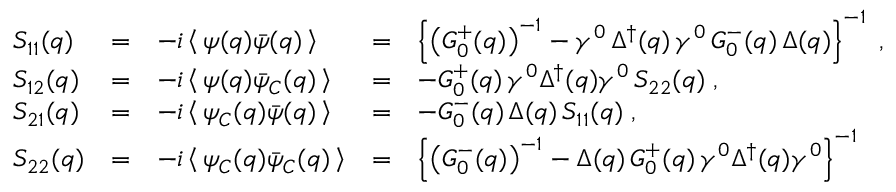Convert formula to latex. <formula><loc_0><loc_0><loc_500><loc_500>\begin{array} { l c l c l } { { S _ { 1 1 } ( q ) } } & { = } & { { - i \left \langle \, \psi ( q ) \bar { \psi } ( q ) \, \right \rangle } } & { = } & { { \left \{ \left ( G _ { 0 } ^ { + } ( q ) \right ) ^ { - 1 } - \gamma ^ { 0 } \, \Delta ^ { \dagger } ( q ) \, \gamma ^ { 0 } \, G _ { 0 } ^ { - } ( q ) \, \Delta ( q ) \right \} ^ { - 1 } \, , } } \\ { { S _ { 1 2 } ( q ) } } & { = } & { { - i \left \langle \, \psi ( q ) \bar { \psi } _ { C } ( q ) \, \right \rangle } } & { = } & { { - G _ { 0 } ^ { + } ( q ) \, \gamma ^ { 0 } \Delta ^ { \dagger } ( q ) \gamma ^ { 0 } \, S _ { 2 2 } ( q ) \, , } } \\ { { S _ { 2 1 } ( q ) } } & { = } & { { - i \left \langle \, \psi _ { C } ( q ) \bar { \psi } ( q ) \, \right \rangle } } & { = } & { { - G _ { 0 } ^ { - } ( q ) \, \Delta ( q ) \, S _ { 1 1 } ( q ) \, , } } \\ { { S _ { 2 2 } ( q ) } } & { = } & { { - i \left \langle \, \psi _ { C } ( q ) \bar { \psi } _ { C } ( q ) \, \right \rangle } } & { = } & { { \left \{ \left ( G _ { 0 } ^ { - } ( q ) \right ) ^ { - 1 } - \Delta ( q ) \, G _ { 0 } ^ { + } ( q ) \, \gamma ^ { 0 } \Delta ^ { \dagger } ( q ) \gamma ^ { 0 } \right \} ^ { - 1 } } } \end{array}</formula> 